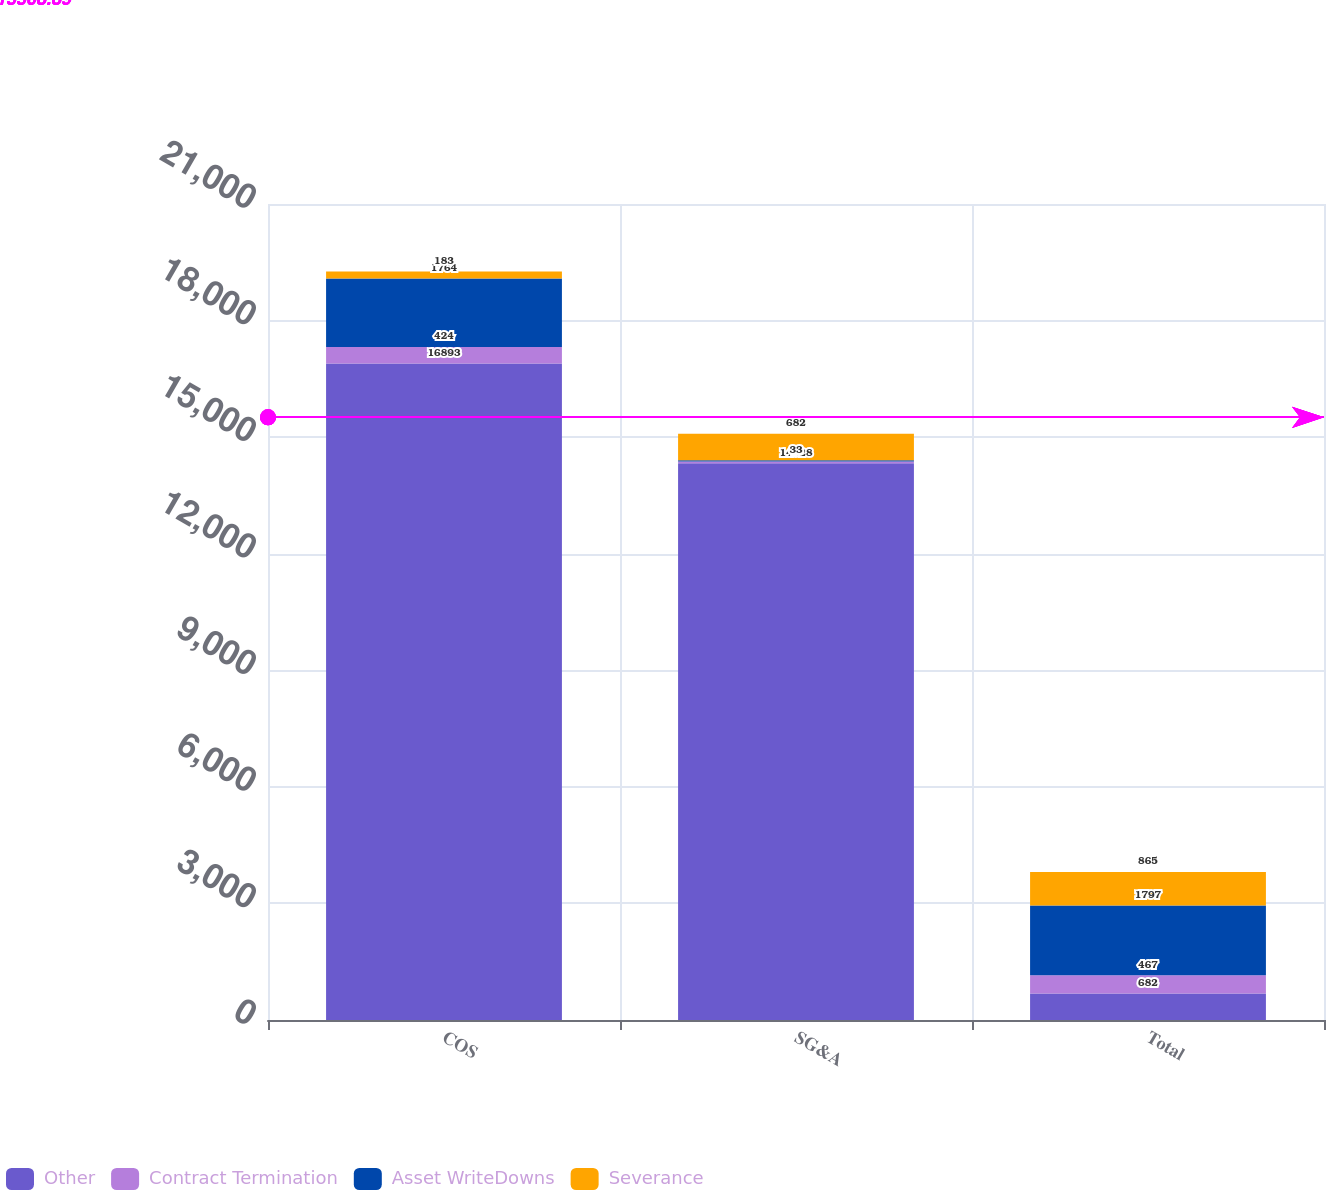Convert chart. <chart><loc_0><loc_0><loc_500><loc_500><stacked_bar_chart><ecel><fcel>COS<fcel>SG&A<fcel>Total<nl><fcel>Other<fcel>16893<fcel>14328<fcel>682<nl><fcel>Contract Termination<fcel>424<fcel>43<fcel>467<nl><fcel>Asset WriteDowns<fcel>1764<fcel>33<fcel>1797<nl><fcel>Severance<fcel>183<fcel>682<fcel>865<nl></chart> 